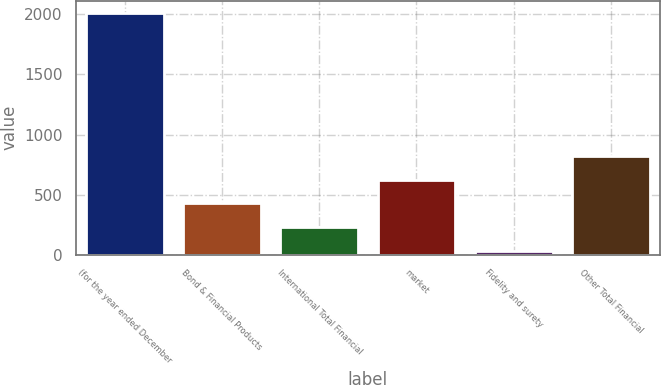Convert chart to OTSL. <chart><loc_0><loc_0><loc_500><loc_500><bar_chart><fcel>(for the year ended December<fcel>Bond & Financial Products<fcel>International Total Financial<fcel>market<fcel>Fidelity and surety<fcel>Other Total Financial<nl><fcel>2012<fcel>426.4<fcel>228.2<fcel>624.6<fcel>30<fcel>822.8<nl></chart> 